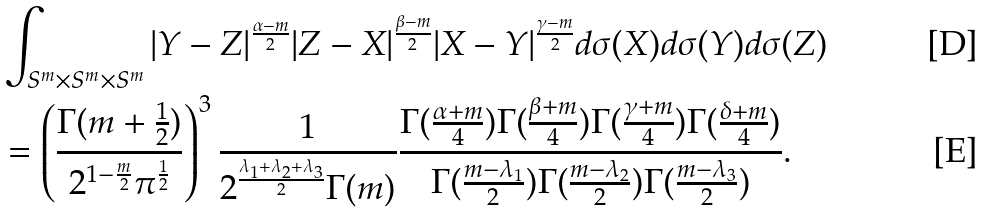Convert formula to latex. <formula><loc_0><loc_0><loc_500><loc_500>& \int _ { S ^ { m } \times S ^ { m } \times S ^ { m } } | Y - Z | ^ { \frac { \alpha - m } { 2 } } | Z - X | ^ { \frac { \beta - m } { 2 } } | X - Y | ^ { \frac { \gamma - m } { 2 } } d \sigma ( X ) d \sigma ( Y ) d \sigma ( Z ) \\ & = \left ( \frac { \Gamma ( m + \frac { 1 } { 2 } ) } { 2 ^ { 1 - \frac { m } { 2 } } \pi ^ { \frac { 1 } { 2 } } } \right ) ^ { 3 } \frac { 1 } { 2 ^ { \frac { \lambda _ { 1 } + \lambda _ { 2 } + \lambda _ { 3 } } { 2 } } \Gamma ( m ) } \frac { \Gamma ( \frac { \alpha + m } { 4 } ) \Gamma ( \frac { \beta + m } { 4 } ) \Gamma ( \frac { \gamma + m } { 4 } ) \Gamma ( \frac { \delta + m } { 4 } ) } { \Gamma ( \frac { m - \lambda _ { 1 } } { 2 } ) \Gamma ( \frac { m - \lambda _ { 2 } } { 2 } ) \Gamma ( \frac { m - \lambda _ { 3 } } { 2 } ) } .</formula> 